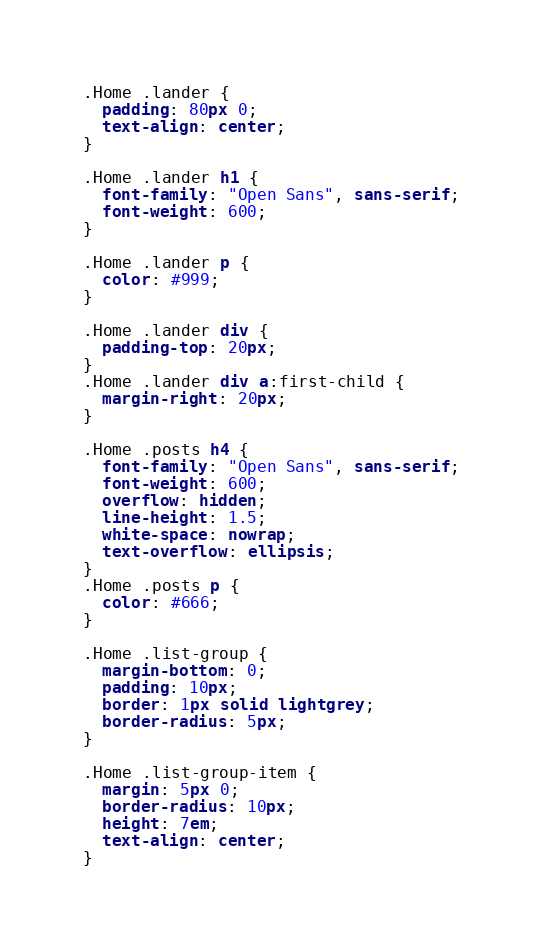Convert code to text. <code><loc_0><loc_0><loc_500><loc_500><_CSS_>.Home .lander {
  padding: 80px 0;
  text-align: center;
}

.Home .lander h1 {
  font-family: "Open Sans", sans-serif;
  font-weight: 600;
}

.Home .lander p {
  color: #999;
}

.Home .lander div {
  padding-top: 20px;
}
.Home .lander div a:first-child {
  margin-right: 20px;
}

.Home .posts h4 {
  font-family: "Open Sans", sans-serif;
  font-weight: 600;
  overflow: hidden;
  line-height: 1.5;
  white-space: nowrap;
  text-overflow: ellipsis;
}
.Home .posts p {
  color: #666;
}

.Home .list-group {
  margin-bottom: 0;
  padding: 10px;
  border: 1px solid lightgrey;
  border-radius: 5px;
}

.Home .list-group-item {
  margin: 5px 0;
  border-radius: 10px;
  height: 7em;
  text-align: center;
}</code> 